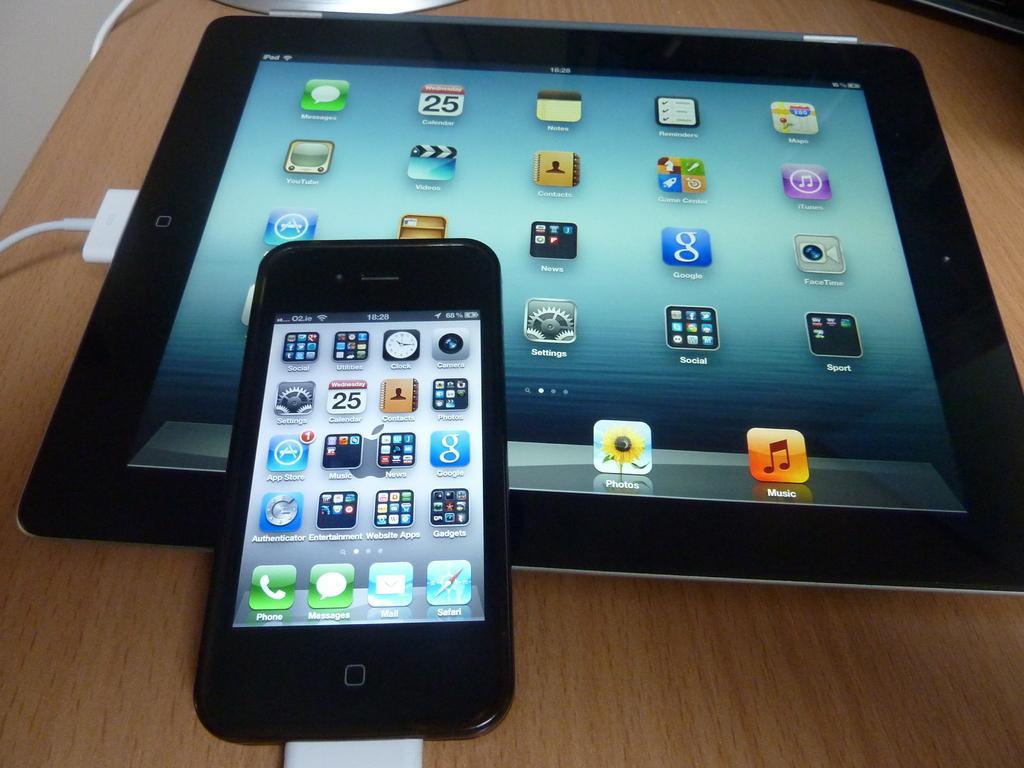Could you give a brief overview of what you see in this image? In this picture I can see the brown color surface on which there is a phone and a tablet and I see 2 white color wires connected to it and on the screens I can see the applications. 